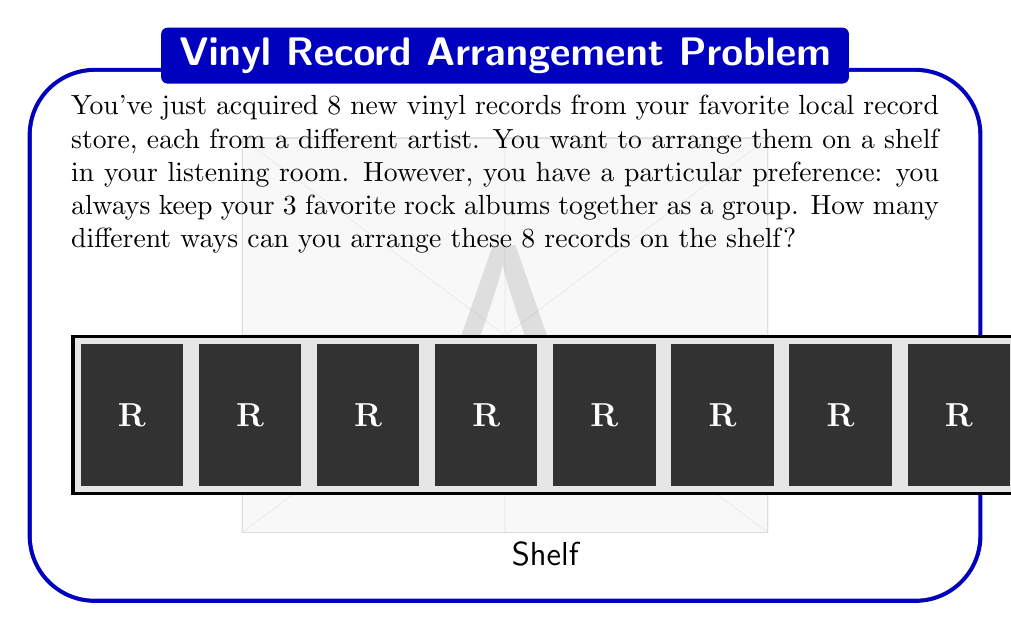Help me with this question. Let's approach this step-by-step:

1) First, we need to consider the 3 favorite rock albums as a single unit. So instead of arranging 8 individual records, we're essentially arranging 6 units (3 rock albums as one unit + 5 other records).

2) The number of ways to arrange 6 distinct units is given by the permutation formula:

   $$P(6,6) = 6! = 6 \times 5 \times 4 \times 3 \times 2 \times 1 = 720$$

3) However, we're not done yet. The 3 rock albums within their group can also be arranged in different ways. The number of ways to arrange 3 items is:

   $$3! = 3 \times 2 \times 1 = 6$$

4) By the multiplication principle, the total number of arrangements is the product of the number of ways to arrange the 6 units and the number of ways to arrange the 3 rock albums within their group:

   $$\text{Total arrangements} = 720 \times 6 = 4,320$$

Therefore, there are 4,320 different ways to arrange these 8 records on the shelf while keeping the 3 favorite rock albums together.
Answer: $4,320$ 